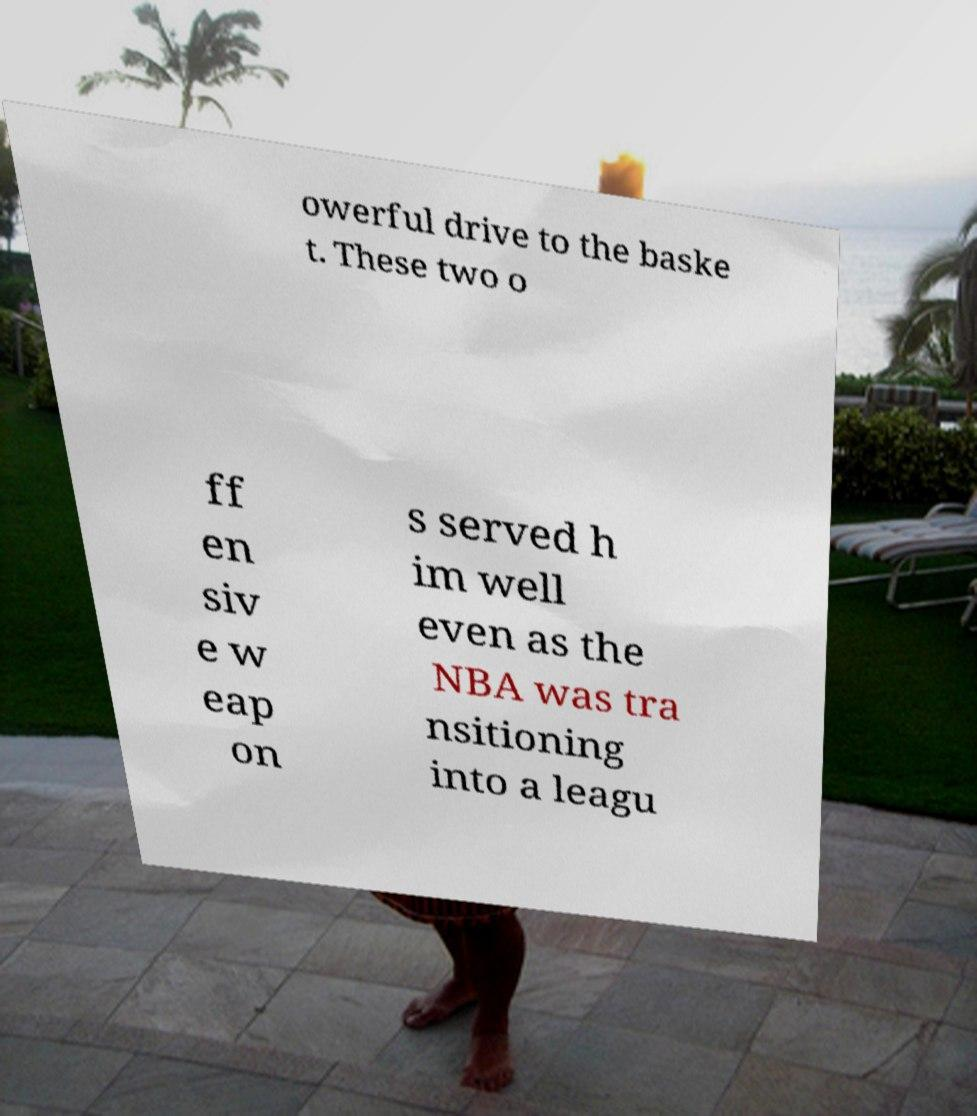Please identify and transcribe the text found in this image. owerful drive to the baske t. These two o ff en siv e w eap on s served h im well even as the NBA was tra nsitioning into a leagu 